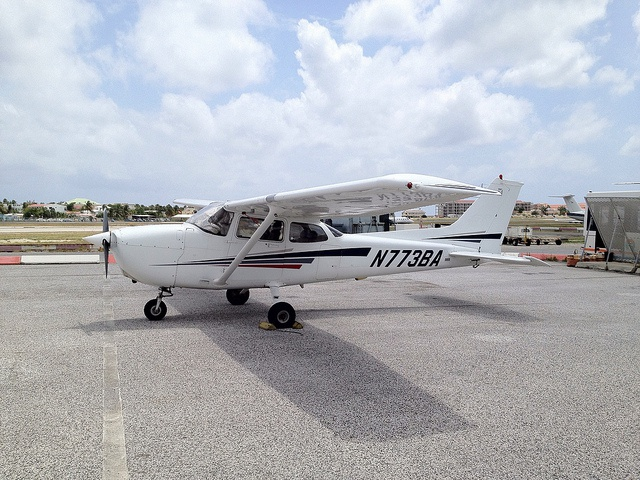Describe the objects in this image and their specific colors. I can see airplane in white, darkgray, gray, lightgray, and black tones and airplane in white, darkgray, gray, lightgray, and black tones in this image. 